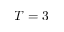Convert formula to latex. <formula><loc_0><loc_0><loc_500><loc_500>T = 3</formula> 